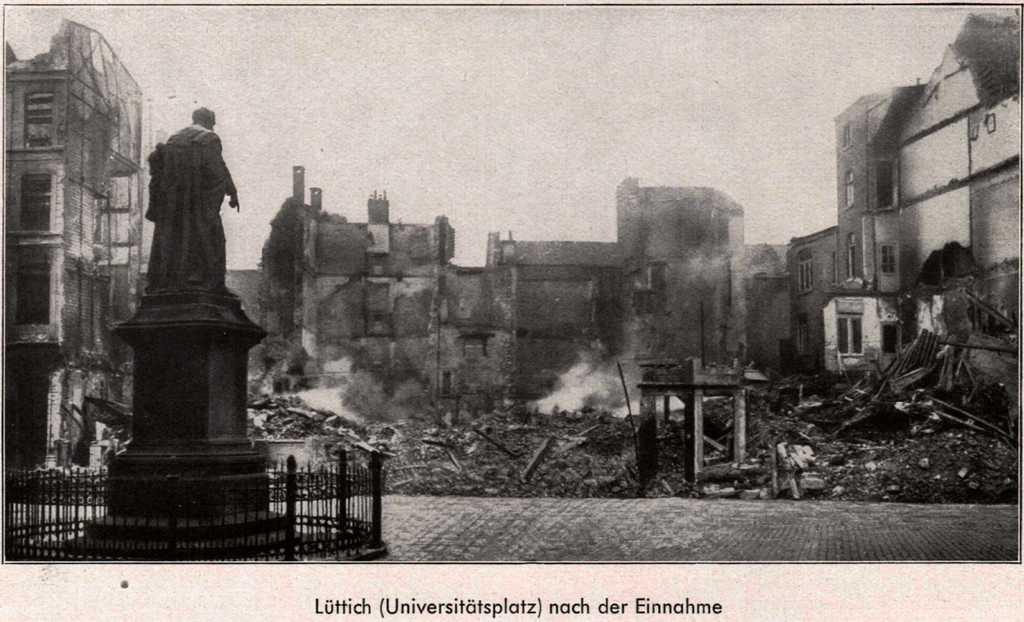What is the color scheme of the image? The image is black and white. What is the main subject in the image? There is a sculpture in the image. What is the condition of the area in front of the sculpture? The area in front of the sculpture is damaged and burnt. What can be seen in the background of the image? There are other buildings around the sculpture. Can you see a parcel being delivered at the seashore in the image? There is no parcel or seashore present in the image; it features a sculpture with damaged and burnt area in front of it and other buildings in the background. Is there an arm reaching out from the sculpture? The image does not show any arms or limbs attached to the sculpture. 